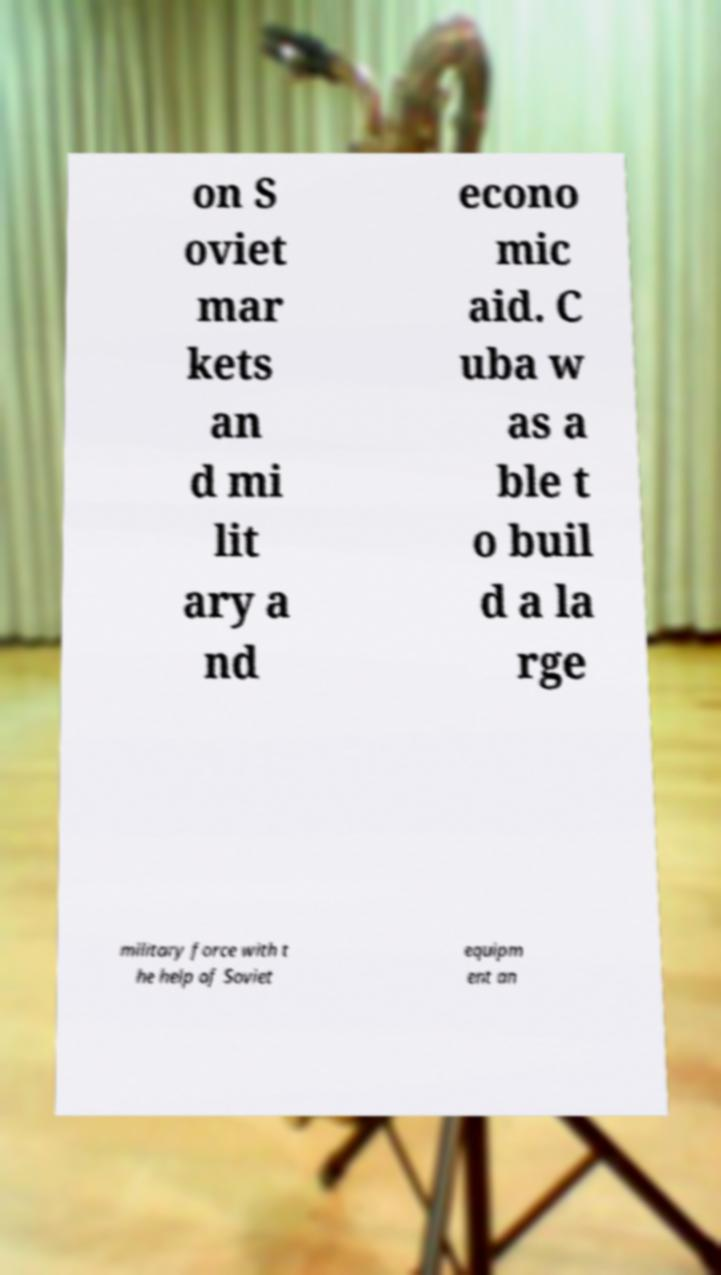Could you assist in decoding the text presented in this image and type it out clearly? on S oviet mar kets an d mi lit ary a nd econo mic aid. C uba w as a ble t o buil d a la rge military force with t he help of Soviet equipm ent an 